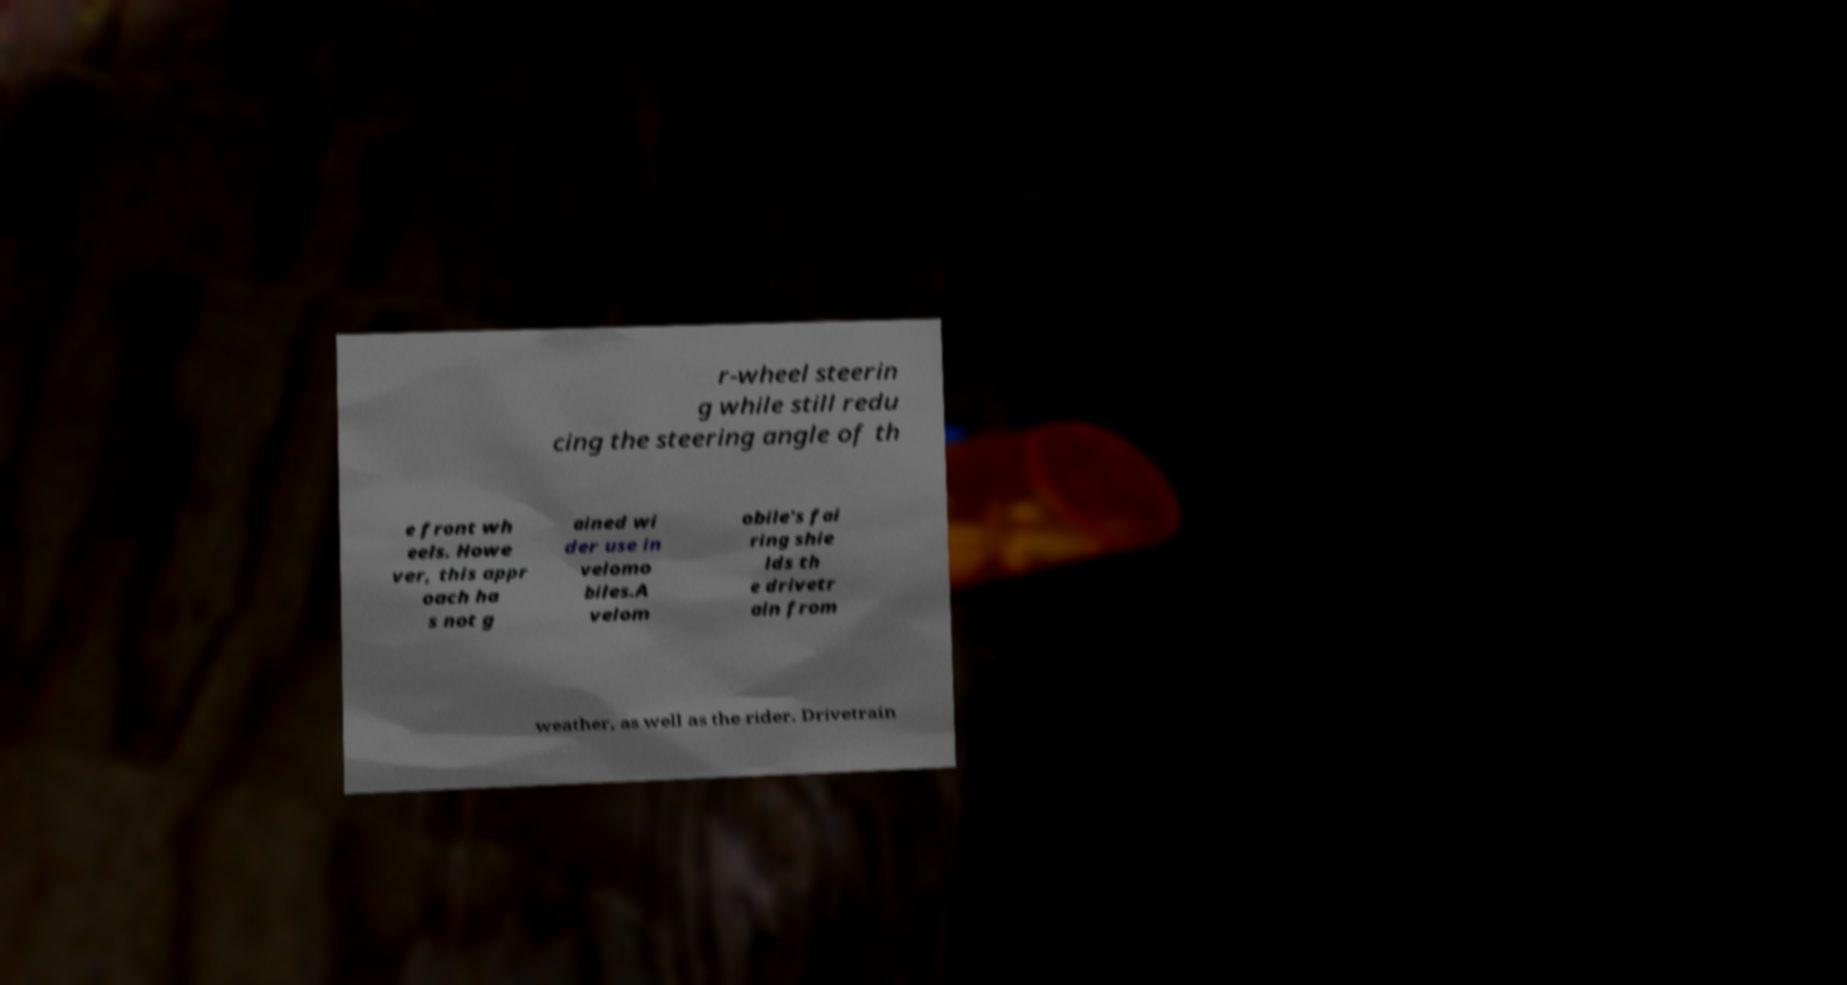I need the written content from this picture converted into text. Can you do that? r-wheel steerin g while still redu cing the steering angle of th e front wh eels. Howe ver, this appr oach ha s not g ained wi der use in velomo biles.A velom obile's fai ring shie lds th e drivetr ain from weather, as well as the rider. Drivetrain 